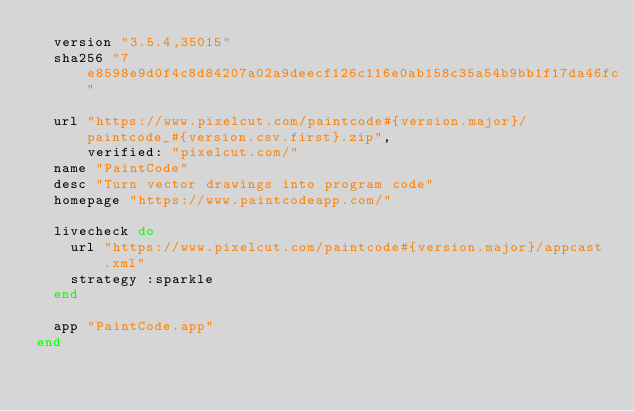Convert code to text. <code><loc_0><loc_0><loc_500><loc_500><_Ruby_>  version "3.5.4,35015"
  sha256 "7e8598e9d0f4c8d84207a02a9deecf126c116e0ab158c35a54b9bb1f17da46fc"

  url "https://www.pixelcut.com/paintcode#{version.major}/paintcode_#{version.csv.first}.zip",
      verified: "pixelcut.com/"
  name "PaintCode"
  desc "Turn vector drawings into program code"
  homepage "https://www.paintcodeapp.com/"

  livecheck do
    url "https://www.pixelcut.com/paintcode#{version.major}/appcast.xml"
    strategy :sparkle
  end

  app "PaintCode.app"
end
</code> 